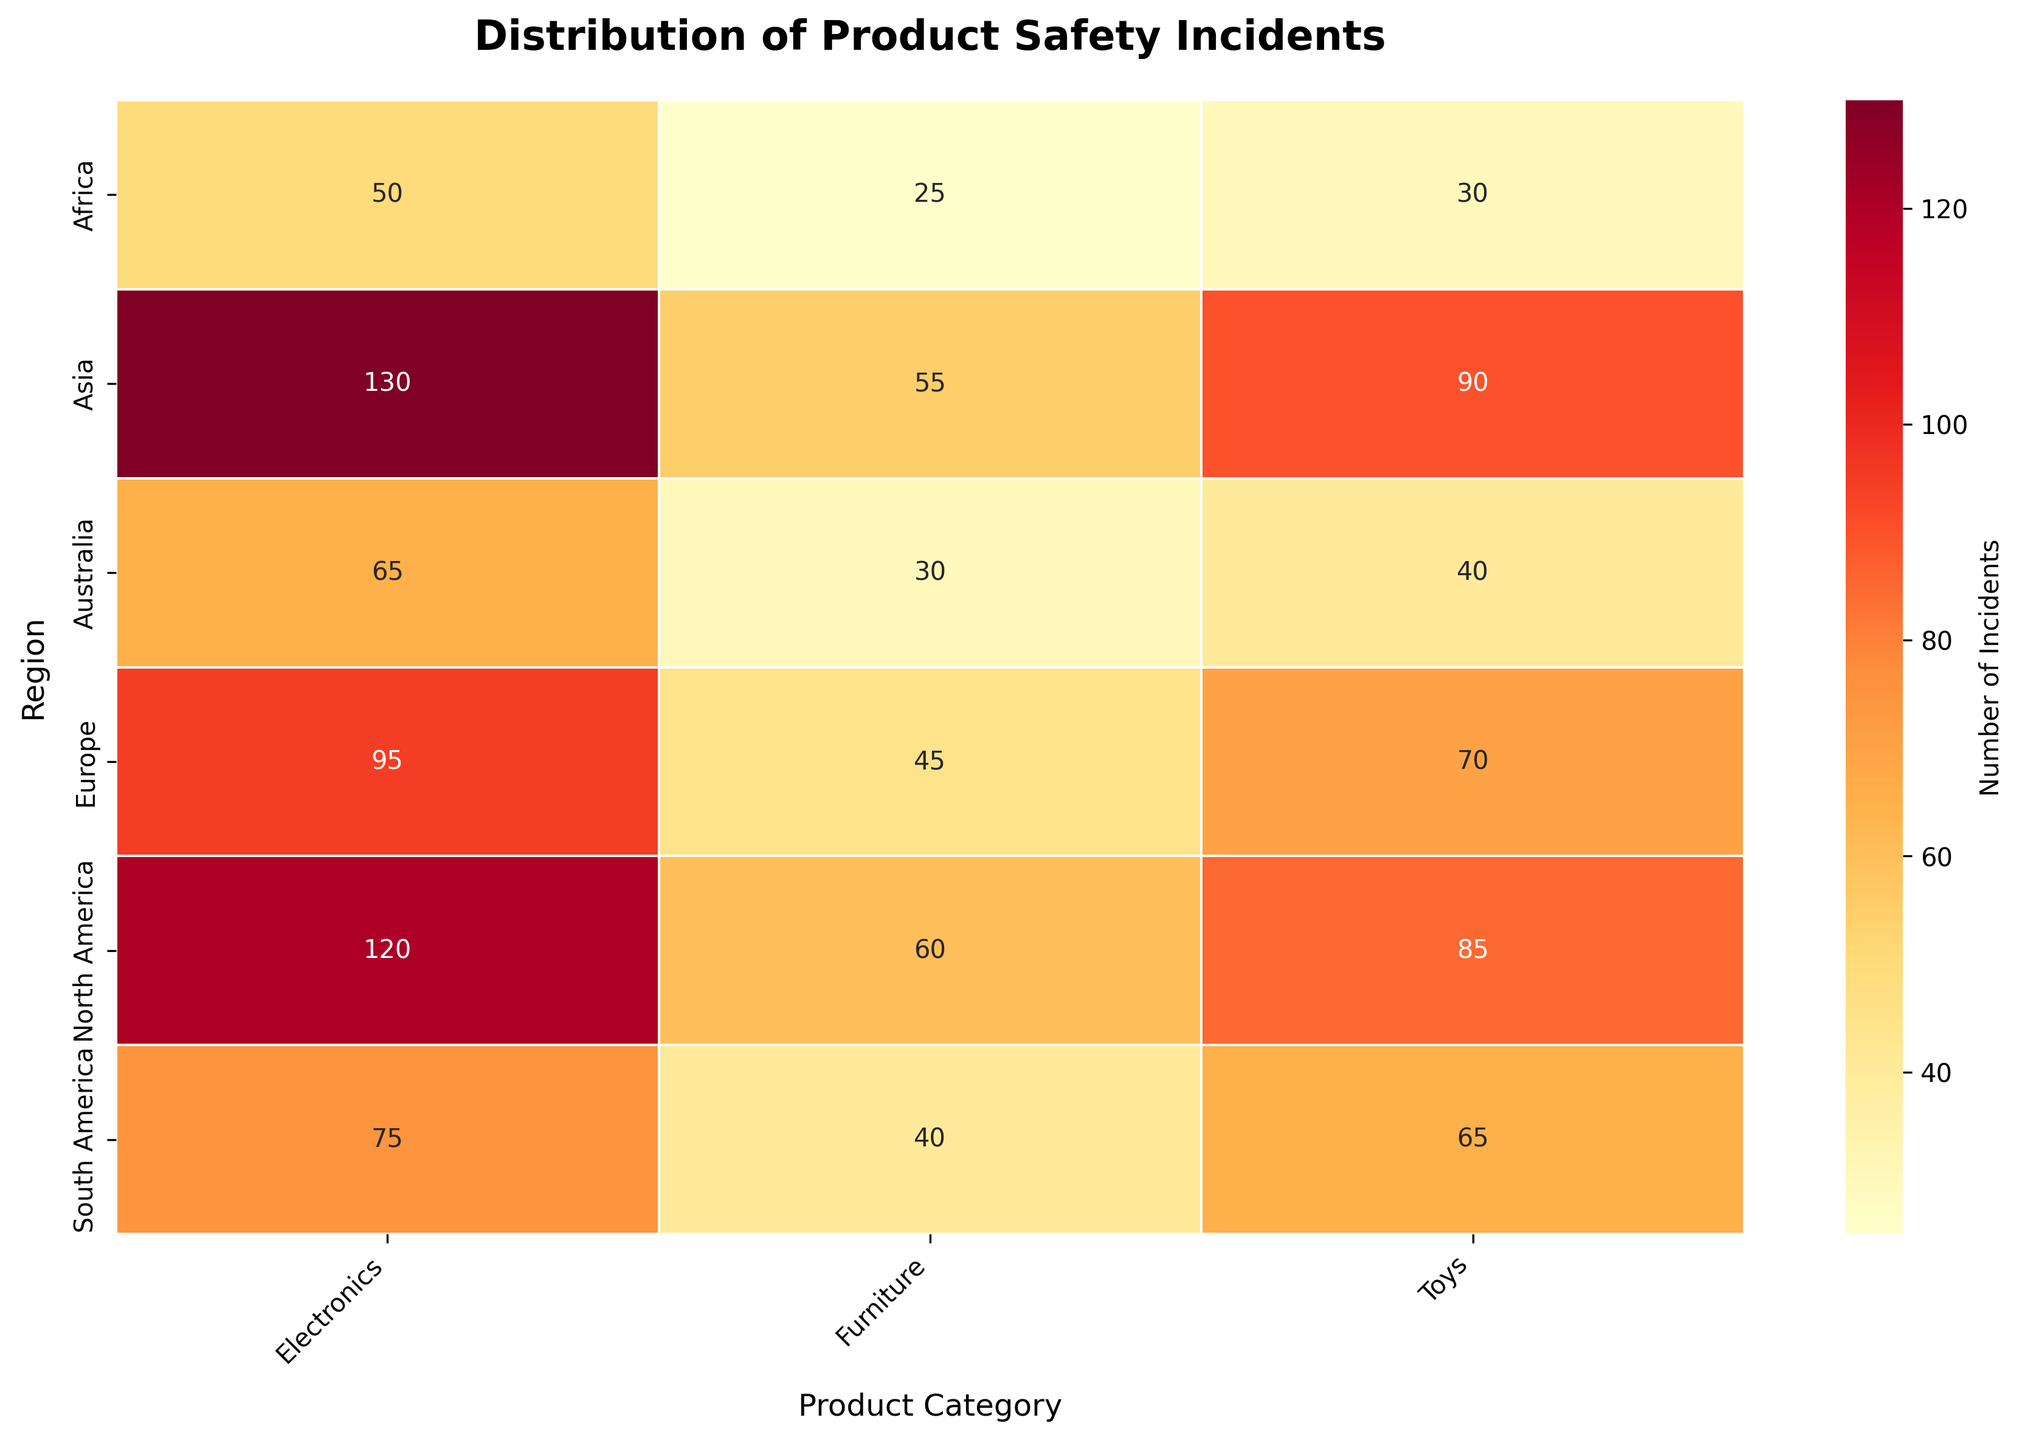What is the incident count for Electronics in Asia? To find the incident count for Electronics in Asia, locate the cell at the intersection of the "Asia" row and "Electronics" column. The value in this cell represents the number of incidents.
Answer: 130 Which region has the highest number of incidents in the Toys category? Compare the values across the "Toys" column and identify the highest value. The region corresponding to this value is the answer.
Answer: Asia What is the sum of incidents reported for Electronics across all regions? Add the incident values for Electronics across all regions: 120 (North America) + 95 (Europe) + 130 (Asia) + 75 (South America) + 50 (Africa) + 65 (Australia). This gives the total number of incidents for Electronics.
Answer: 535 Is the number of furniture incidents in Africa greater than in South America? Compare the incident count for Furniture in Africa with that in South America. The count in Africa is 25, while in South America it is 40.
Answer: No What is the average number of incidents reported per category in North America? Find the incidents for each category in North America (Electronics: 120, Toys: 85, Furniture: 60), then calculate the average by summing these values and dividing by the number of categories (3). (120 + 85 + 60) / 3.
Answer: 88.33 Which product category has the lowest incidents in Europe? Compare the incident counts within Europe across all product categories: Electronics (95), Toys (70), and Furniture (45). The lowest value corresponds to the product category with the fewest incidents.
Answer: Furniture Is the incident count for Toys in Asia higher than the total incident count for Furniture in Europe and Australia combined? Check the incident count for Toys in Asia (90) and compare it with the sum of incidents for Furniture in Europe (45) and Australia (30), which is 45 + 30 = 75.
Answer: Yes How many regions report more than 100 incidents for any product category? Identify the regions with incident counts above 100 in any product category: Asia (Electronics: 130) and North America (Electronics: 120). Count the distinct regions.
Answer: 2 What is the difference in incident counts between Electronics in North America and Europe? Subtract the incident count for Electronics in Europe (95) from the count in North America (120). 120 - 95.
Answer: 25 